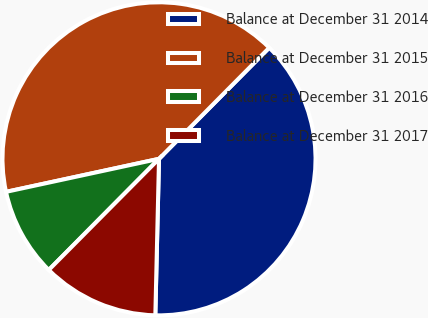<chart> <loc_0><loc_0><loc_500><loc_500><pie_chart><fcel>Balance at December 31 2014<fcel>Balance at December 31 2015<fcel>Balance at December 31 2016<fcel>Balance at December 31 2017<nl><fcel>37.94%<fcel>40.82%<fcel>9.18%<fcel>12.06%<nl></chart> 